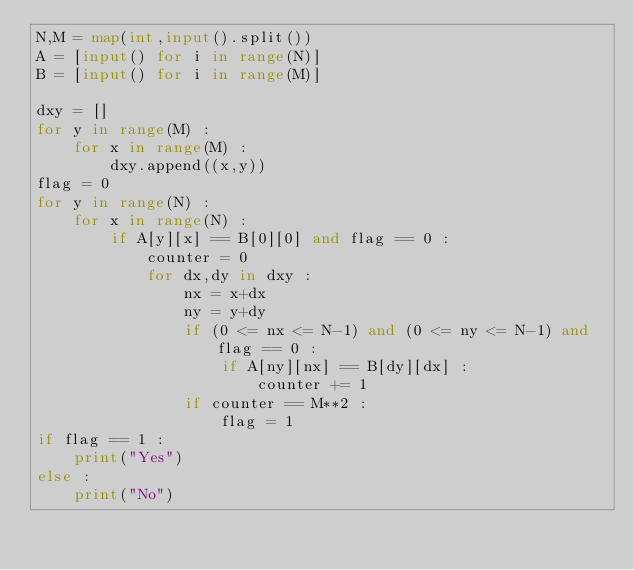Convert code to text. <code><loc_0><loc_0><loc_500><loc_500><_Python_>N,M = map(int,input().split())
A = [input() for i in range(N)]
B = [input() for i in range(M)]

dxy = []
for y in range(M) :
    for x in range(M) :
        dxy.append((x,y))
flag = 0
for y in range(N) :
    for x in range(N) :
        if A[y][x] == B[0][0] and flag == 0 :
            counter = 0
            for dx,dy in dxy :
                nx = x+dx
                ny = y+dy
                if (0 <= nx <= N-1) and (0 <= ny <= N-1) and flag == 0 :
                    if A[ny][nx] == B[dy][dx] :
                        counter += 1
                if counter == M**2 :
                    flag = 1
if flag == 1 :
    print("Yes")
else :
    print("No")
</code> 